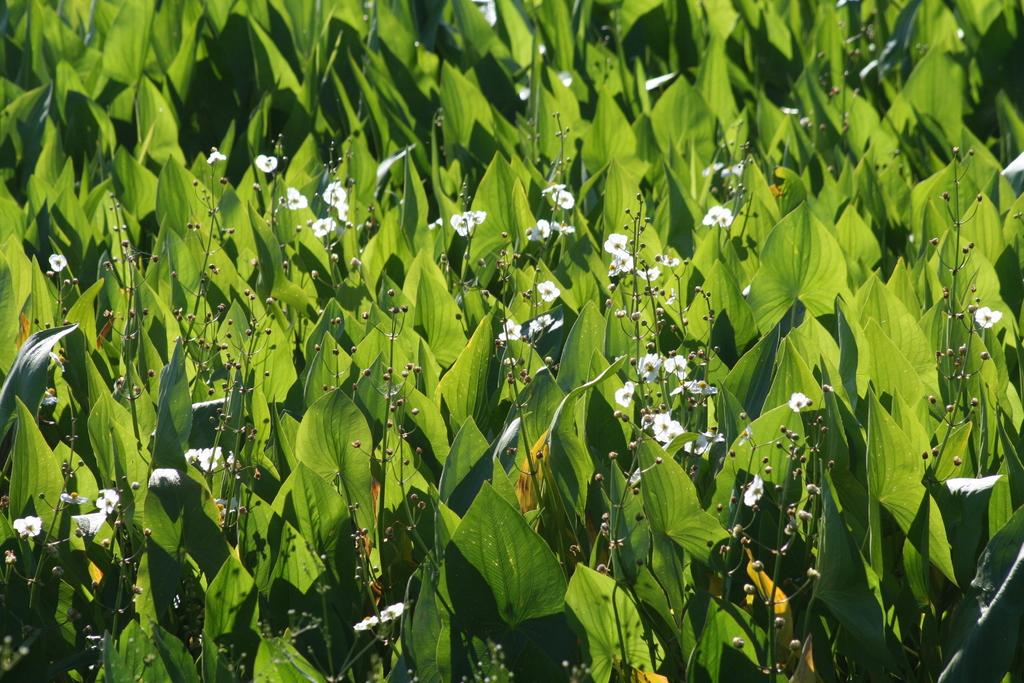What type of vegetation can be seen in the image? There are many plants in the image. What color are the leaves of the plants in the image? Green leaves are present in the image. What additional features can be seen on the plants in the image? Flowers and stems are visible in the image. What type of insurance policy is being discussed by the plants in the image? There are no discussions or insurance policies present in the image; it features plants with green leaves, flowers, and stems. 